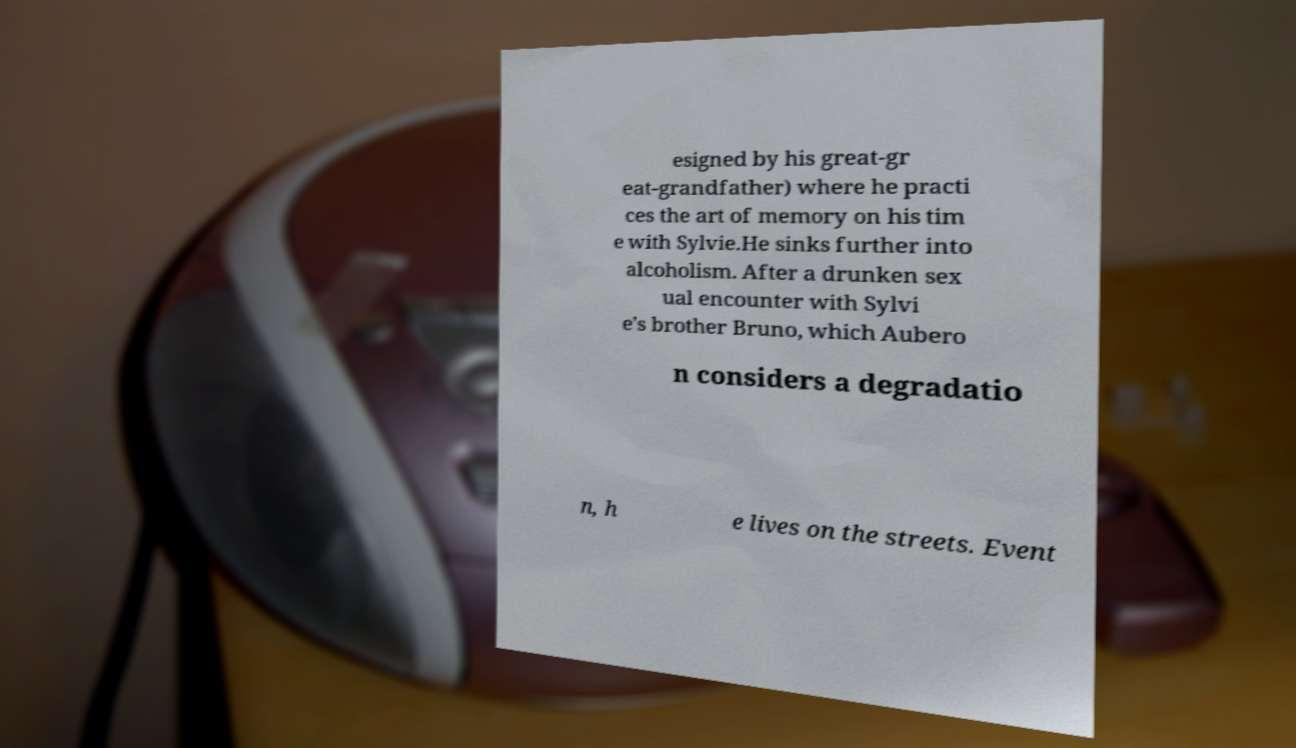Can you read and provide the text displayed in the image?This photo seems to have some interesting text. Can you extract and type it out for me? esigned by his great-gr eat-grandfather) where he practi ces the art of memory on his tim e with Sylvie.He sinks further into alcoholism. After a drunken sex ual encounter with Sylvi e’s brother Bruno, which Aubero n considers a degradatio n, h e lives on the streets. Event 